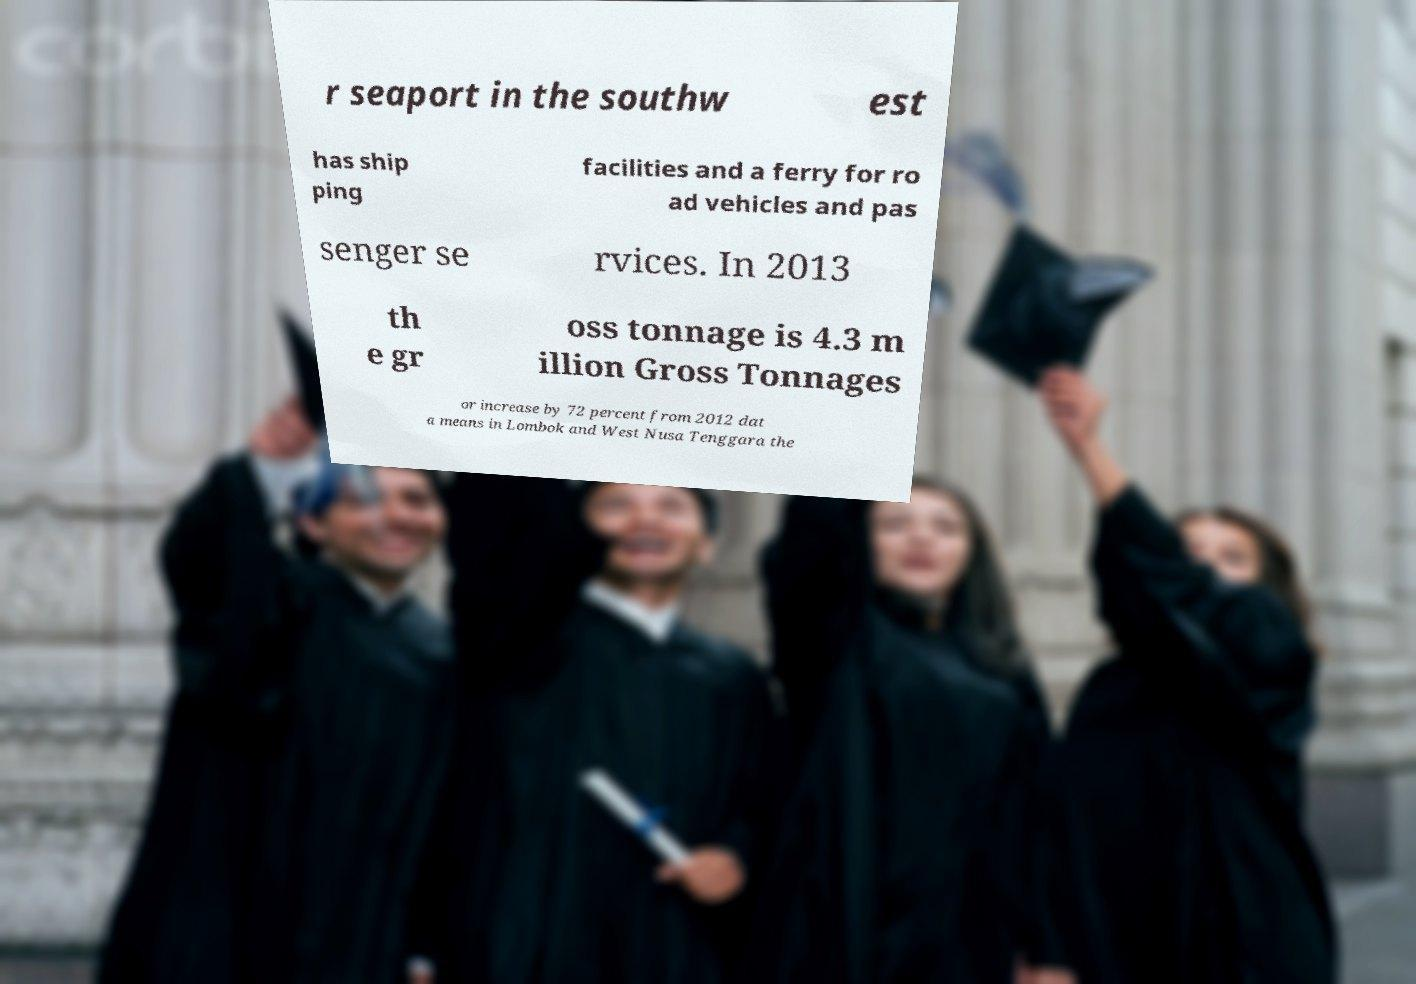Could you assist in decoding the text presented in this image and type it out clearly? r seaport in the southw est has ship ping facilities and a ferry for ro ad vehicles and pas senger se rvices. In 2013 th e gr oss tonnage is 4.3 m illion Gross Tonnages or increase by 72 percent from 2012 dat a means in Lombok and West Nusa Tenggara the 